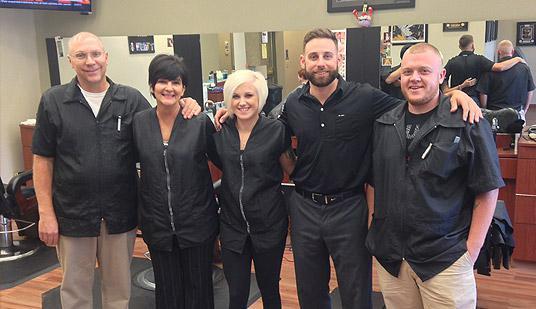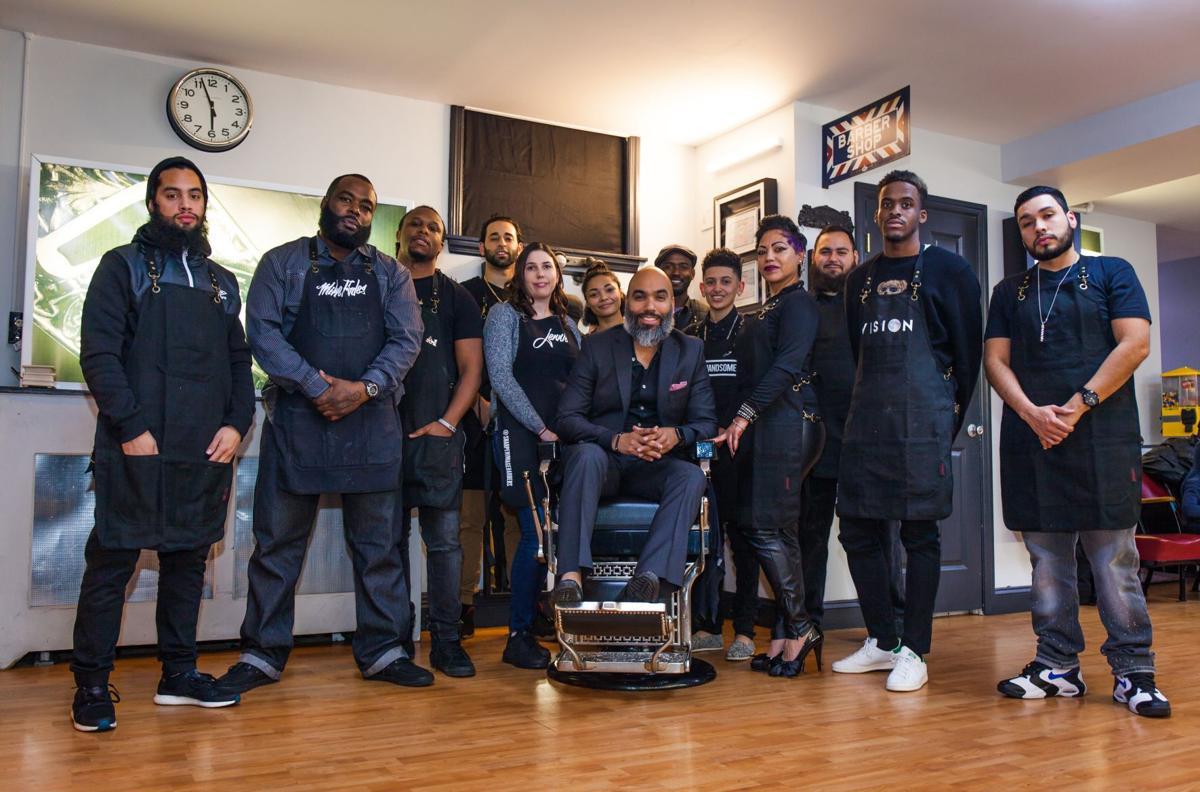The first image is the image on the left, the second image is the image on the right. Given the left and right images, does the statement "In at least one image there are four people in black shirts." hold true? Answer yes or no. No. The first image is the image on the left, the second image is the image on the right. Analyze the images presented: Is the assertion "In the center of one of the images there is a man with a beard sitting in a barber's chair surrounded by people." valid? Answer yes or no. Yes. 